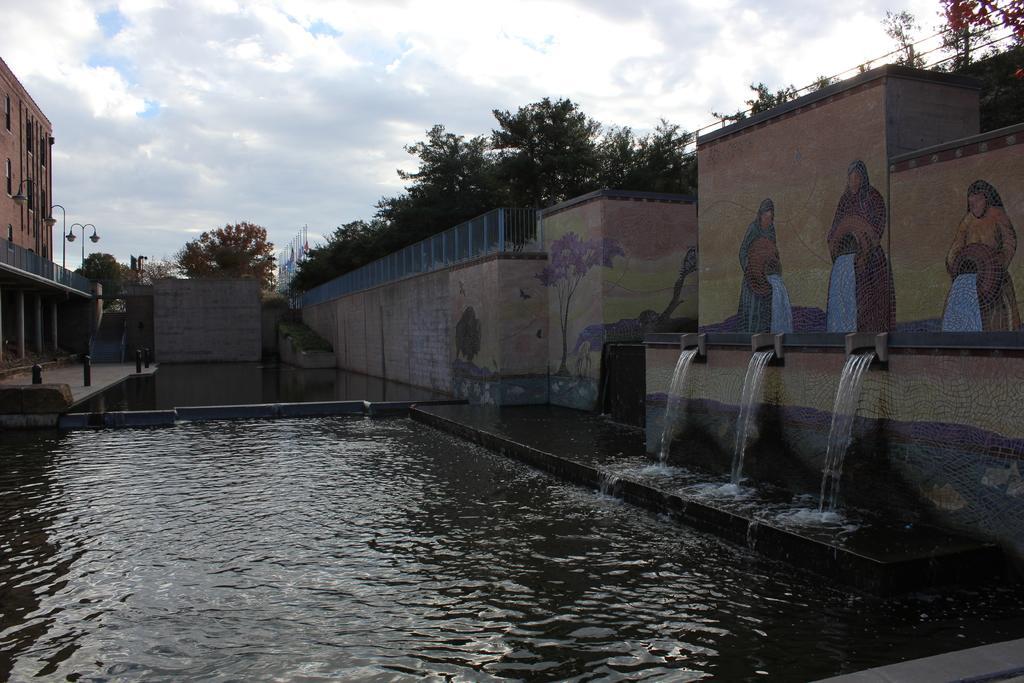In one or two sentences, can you explain what this image depicts? In this picture we can see water, painting on walls, railings, building, poles, lights and steps. In the background of the image we can see trees, objects and sky with clouds. 